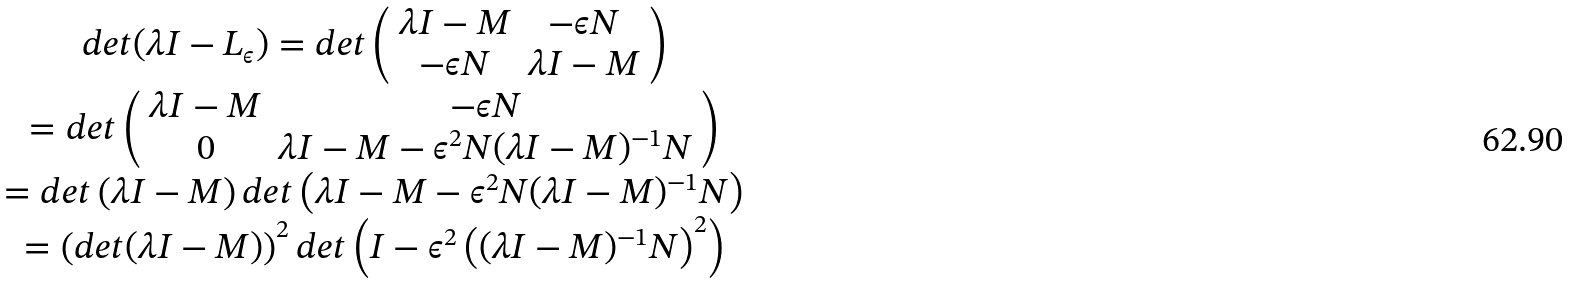<formula> <loc_0><loc_0><loc_500><loc_500>\begin{array} { c c } d e t ( \lambda I - L _ { \epsilon } ) = d e t \left ( \begin{array} { c c } \lambda I - M & - \epsilon N \\ - \epsilon N & \lambda I - M \end{array} \right ) \\ = d e t \left ( \begin{array} { c c } \lambda I - M & - \epsilon N \\ 0 & \lambda I - M - \epsilon ^ { 2 } N ( \lambda I - M ) ^ { - 1 } N \end{array} \right ) \\ = d e t \left ( \lambda I - M \right ) d e t \left ( \lambda I - M - \epsilon ^ { 2 } N ( \lambda I - M ) ^ { - 1 } N \right ) \\ = \left ( d e t ( \lambda I - M ) \right ) ^ { 2 } d e t \left ( I - \epsilon ^ { 2 } \left ( ( \lambda I - M ) ^ { - 1 } N \right ) ^ { 2 } \right ) \end{array}</formula> 